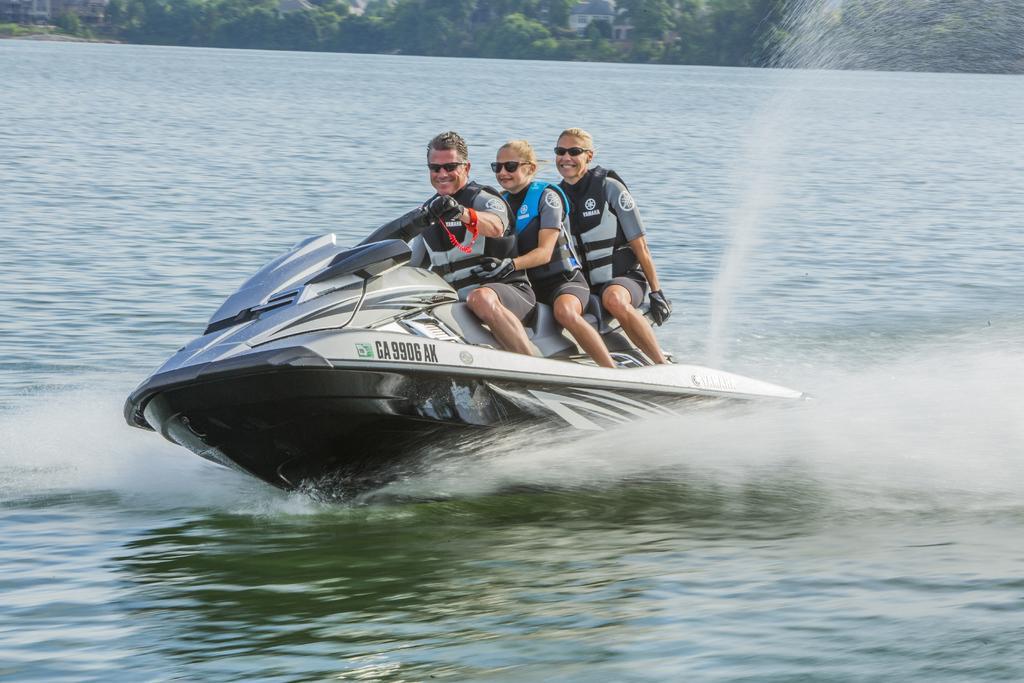How would you summarize this image in a sentence or two? In this picture we can see there are three persons sitting on a "Jet Ski" which is on the water. At the top of the image, there are trees and buildings. 